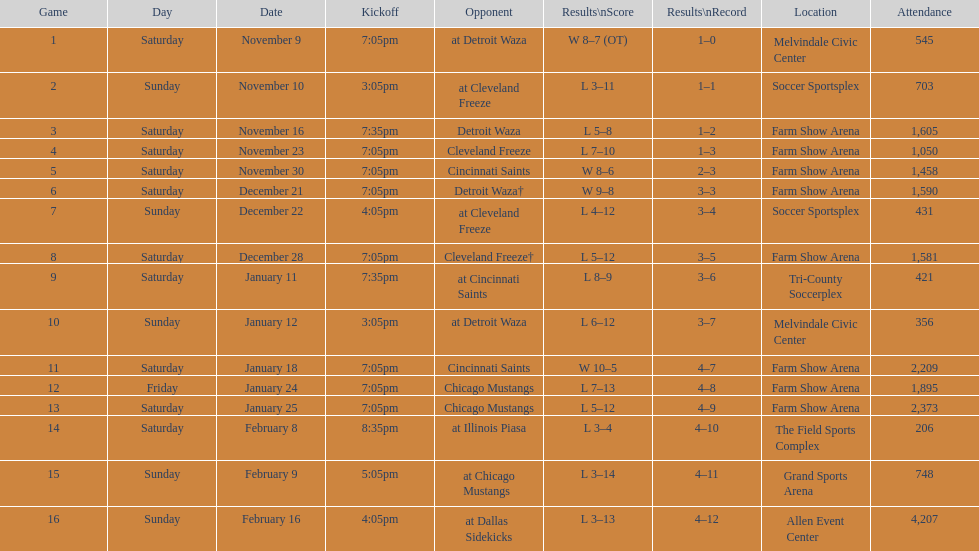How long was the teams longest losing streak? 5 games. 